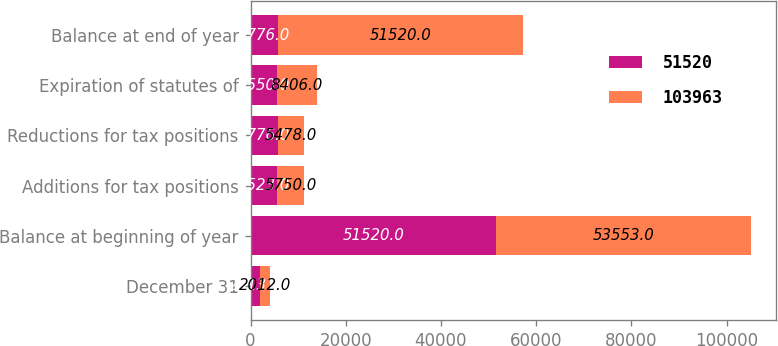Convert chart. <chart><loc_0><loc_0><loc_500><loc_500><stacked_bar_chart><ecel><fcel>December 31<fcel>Balance at beginning of year<fcel>Additions for tax positions<fcel>Reductions for tax positions<fcel>Expiration of statutes of<fcel>Balance at end of year<nl><fcel>51520<fcel>2013<fcel>51520<fcel>5523<fcel>5776<fcel>5550<fcel>5776<nl><fcel>103963<fcel>2012<fcel>53553<fcel>5750<fcel>5478<fcel>8406<fcel>51520<nl></chart> 